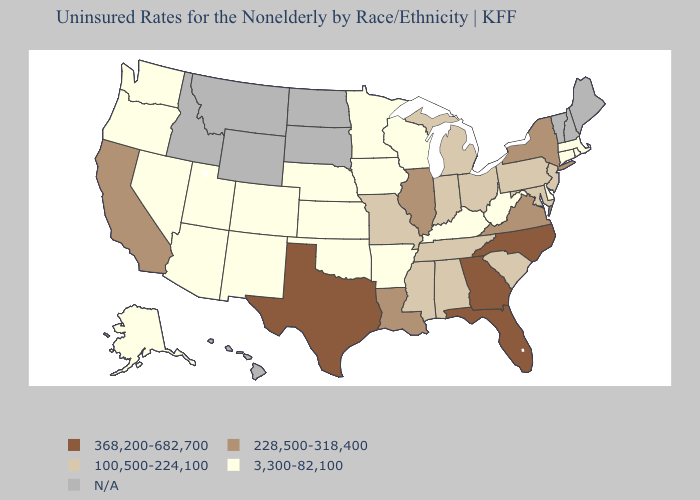Does Texas have the highest value in the USA?
Concise answer only. Yes. What is the lowest value in the USA?
Be succinct. 3,300-82,100. Among the states that border Pennsylvania , which have the lowest value?
Quick response, please. Delaware, West Virginia. Which states have the highest value in the USA?
Keep it brief. Florida, Georgia, North Carolina, Texas. What is the value of California?
Concise answer only. 228,500-318,400. Which states have the highest value in the USA?
Concise answer only. Florida, Georgia, North Carolina, Texas. What is the value of Colorado?
Give a very brief answer. 3,300-82,100. Name the states that have a value in the range 368,200-682,700?
Write a very short answer. Florida, Georgia, North Carolina, Texas. Which states have the lowest value in the USA?
Give a very brief answer. Alaska, Arizona, Arkansas, Colorado, Connecticut, Delaware, Iowa, Kansas, Kentucky, Massachusetts, Minnesota, Nebraska, Nevada, New Mexico, Oklahoma, Oregon, Rhode Island, Utah, Washington, West Virginia, Wisconsin. Name the states that have a value in the range N/A?
Give a very brief answer. Hawaii, Idaho, Maine, Montana, New Hampshire, North Dakota, South Dakota, Vermont, Wyoming. Is the legend a continuous bar?
Give a very brief answer. No. Name the states that have a value in the range N/A?
Write a very short answer. Hawaii, Idaho, Maine, Montana, New Hampshire, North Dakota, South Dakota, Vermont, Wyoming. What is the value of Florida?
Write a very short answer. 368,200-682,700. Name the states that have a value in the range 3,300-82,100?
Write a very short answer. Alaska, Arizona, Arkansas, Colorado, Connecticut, Delaware, Iowa, Kansas, Kentucky, Massachusetts, Minnesota, Nebraska, Nevada, New Mexico, Oklahoma, Oregon, Rhode Island, Utah, Washington, West Virginia, Wisconsin. Name the states that have a value in the range 3,300-82,100?
Quick response, please. Alaska, Arizona, Arkansas, Colorado, Connecticut, Delaware, Iowa, Kansas, Kentucky, Massachusetts, Minnesota, Nebraska, Nevada, New Mexico, Oklahoma, Oregon, Rhode Island, Utah, Washington, West Virginia, Wisconsin. 